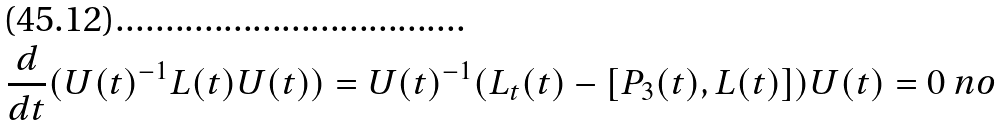<formula> <loc_0><loc_0><loc_500><loc_500>\frac { d } { d t } ( U ( t ) ^ { - 1 } L ( t ) U ( t ) ) = U ( t ) ^ { - 1 } ( L _ { t } ( t ) - [ P _ { 3 } ( t ) , L ( t ) ] ) U ( t ) = 0 \ n o</formula> 